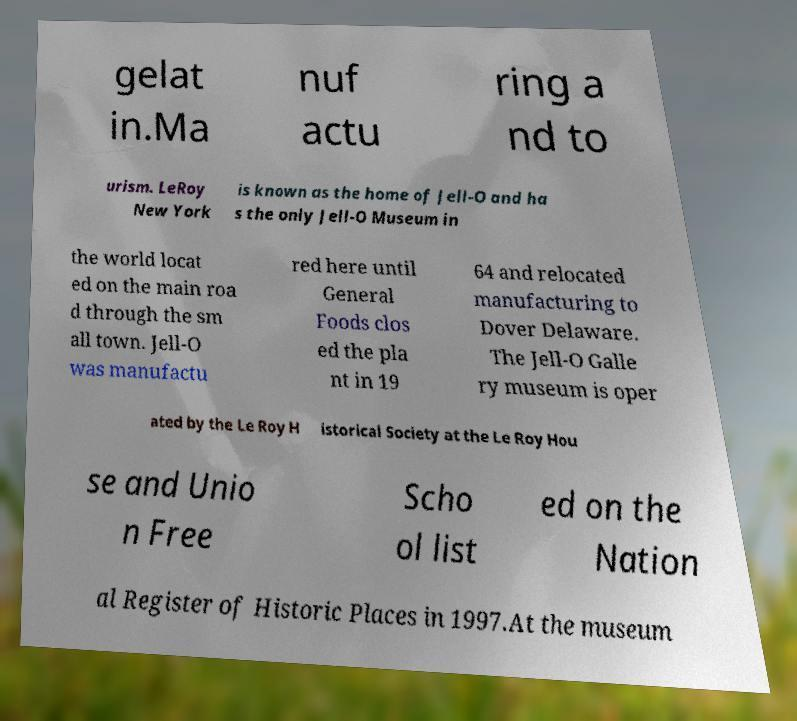Please read and relay the text visible in this image. What does it say? gelat in.Ma nuf actu ring a nd to urism. LeRoy New York is known as the home of Jell-O and ha s the only Jell-O Museum in the world locat ed on the main roa d through the sm all town. Jell-O was manufactu red here until General Foods clos ed the pla nt in 19 64 and relocated manufacturing to Dover Delaware. The Jell-O Galle ry museum is oper ated by the Le Roy H istorical Society at the Le Roy Hou se and Unio n Free Scho ol list ed on the Nation al Register of Historic Places in 1997.At the museum 